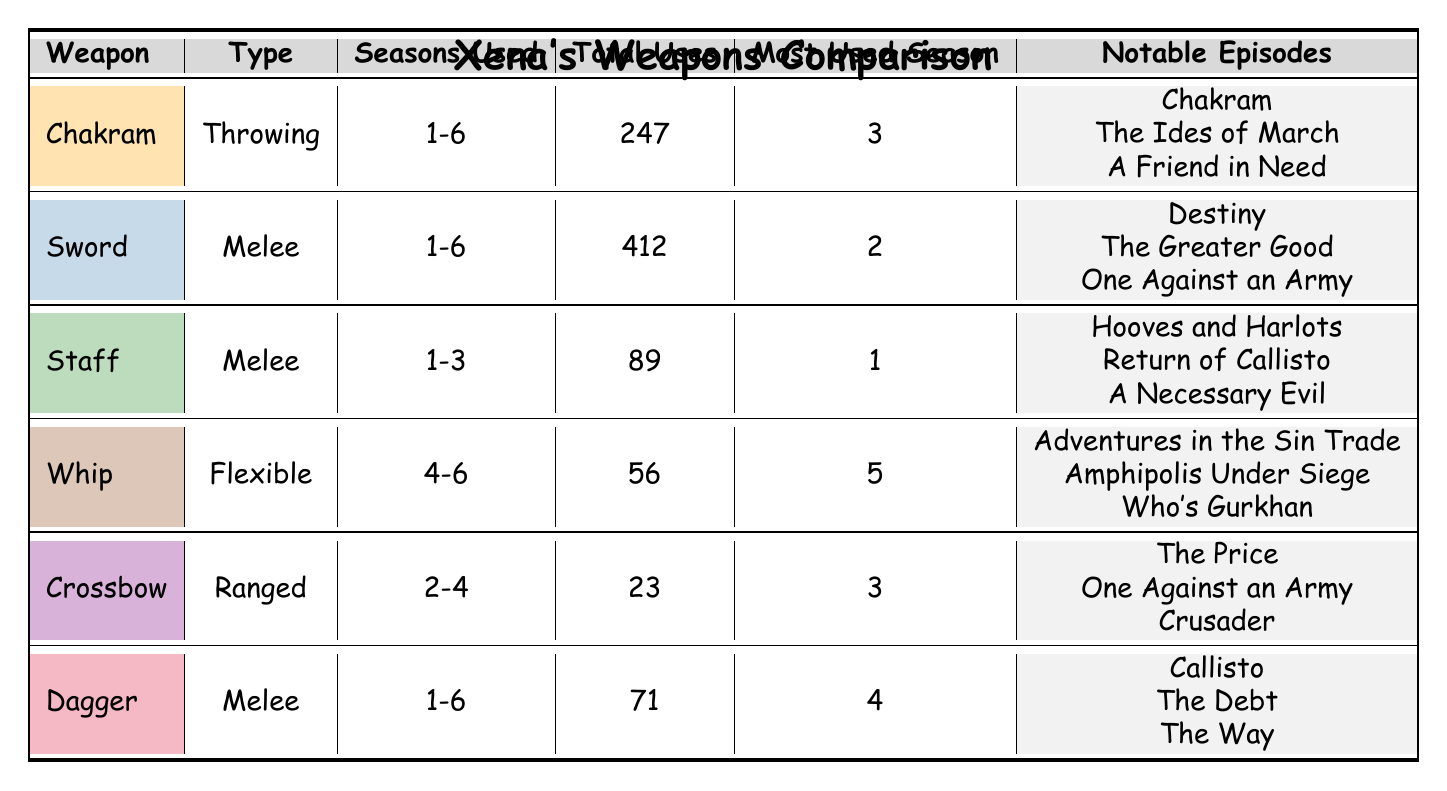What is the total number of uses for the Sword? The table explicitly states that the Sword has a total of 412 uses.
Answer: 412 Which weapon has the highest total uses? Comparing the total uses of each weapon in the table, the Sword has 412 uses, while the Chakram follows with 247 uses; thus, the Sword has the highest total.
Answer: Sword How many seasons was the Staff used? The Staff is indicated to have been used in Seasons 1, 2, and 3, totaling 3 seasons.
Answer: 3 What is the most used season for the Dagger? The table shows that the Dagger was most used in Season 4.
Answer: 4 Is the Whip used more frequently than the Crossbow? The Whip has 56 total uses, while the Crossbow has 23; therefore, the Whip is used more frequently than the Crossbow.
Answer: Yes What is the total number of uses for all weapons combined? Summing the total uses: 247 (Chakram) + 412 (Sword) + 89 (Staff) + 56 (Whip) + 23 (Crossbow) + 71 (Dagger) equals 898 total uses.
Answer: 898 Which season saw the most use of the Chakram? According to the table, the most used season for the Chakram is Season 3, where it was used the most compared to the other seasons.
Answer: 3 What type of weapon is the Crossbow classified as? The table clearly categorizes the Crossbow as a Ranged weapon.
Answer: Ranged Was the Staff ever used in Season 4? The table indicates that the Staff was only used in Seasons 1, 2, and 3, so it was not used in Season 4.
Answer: No What is the average number of uses for the Chakram and the Dagger? To find the average, add their total uses: 247 (Chakram) + 71 (Dagger) = 318. Then divide by 2 for the average: 318/2 = 159.
Answer: 159 